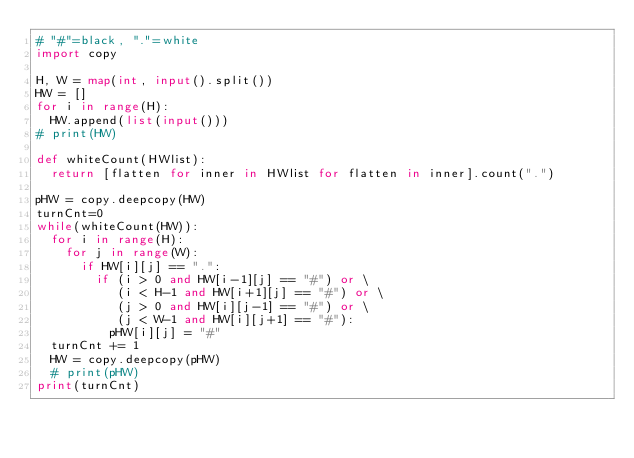<code> <loc_0><loc_0><loc_500><loc_500><_Python_># "#"=black, "."=white
import copy

H, W = map(int, input().split())
HW = []
for i in range(H):
  HW.append(list(input()))
# print(HW)

def whiteCount(HWlist):
  return [flatten for inner in HWlist for flatten in inner].count(".")    

pHW = copy.deepcopy(HW)
turnCnt=0
while(whiteCount(HW)):
  for i in range(H):
    for j in range(W):
      if HW[i][j] == ".":
        if (i > 0 and HW[i-1][j] == "#") or \
           (i < H-1 and HW[i+1][j] == "#") or \
           (j > 0 and HW[i][j-1] == "#") or \
           (j < W-1 and HW[i][j+1] == "#"):
          pHW[i][j] = "#"
  turnCnt += 1
  HW = copy.deepcopy(pHW)
  # print(pHW)
print(turnCnt)
</code> 